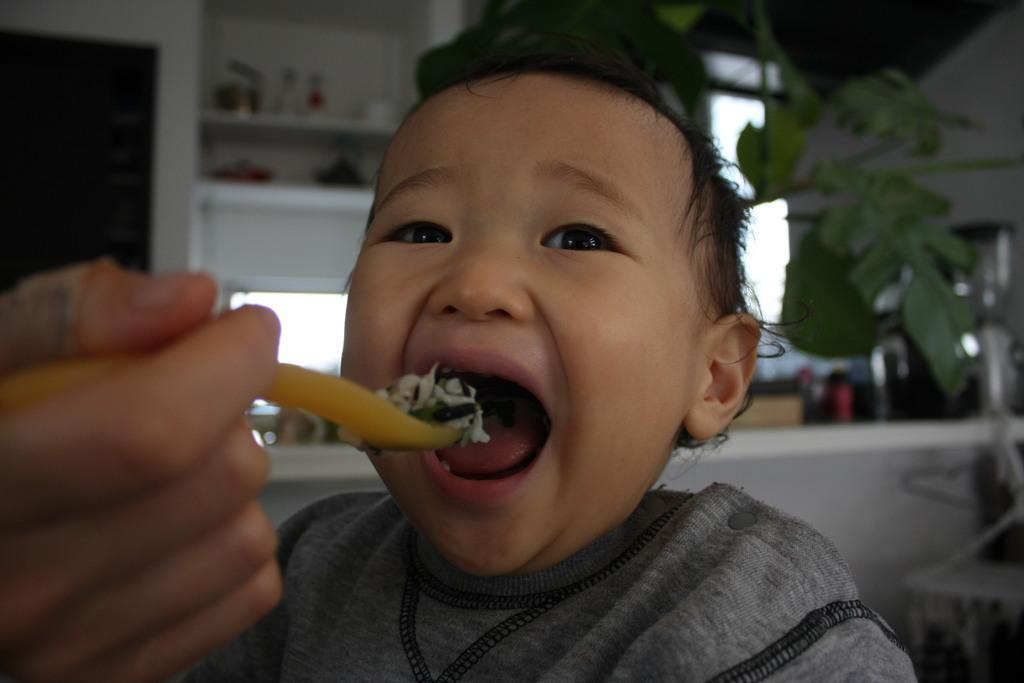How would you summarize this image in a sentence or two? In this image I can see a person wearing gray color shirt. In front I can see a human hand holding a spoon and the spoon is in yellow color. Background I can see a small plant in green color and a window. 